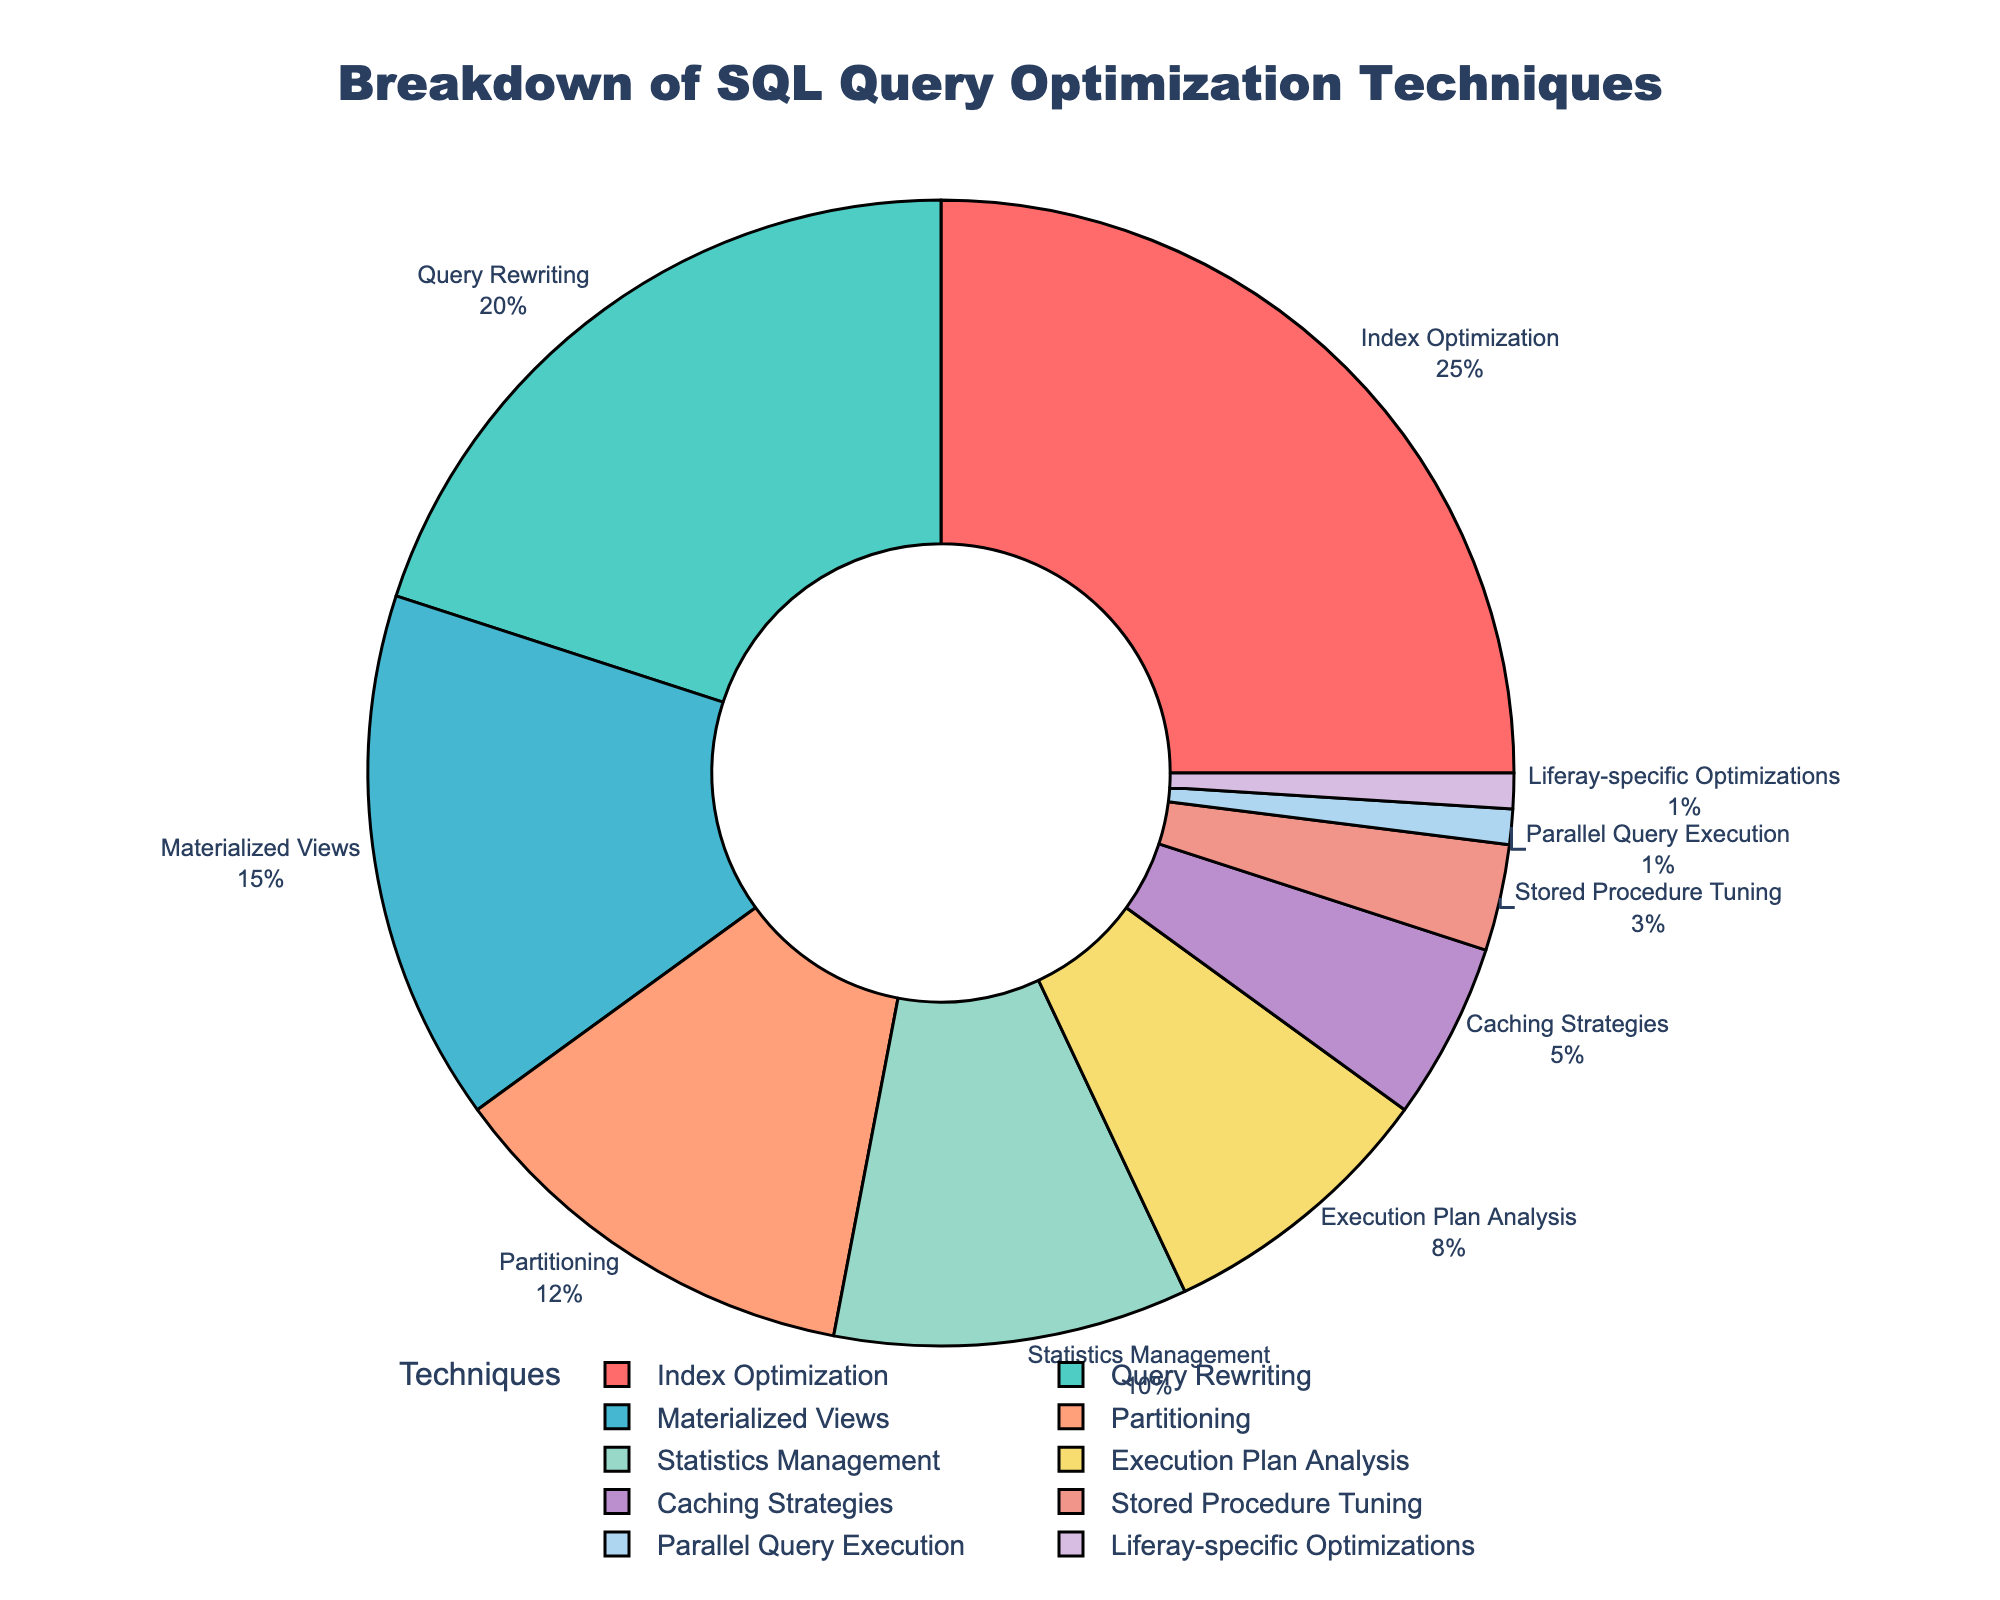What's the most frequently employed SQL query optimization technique according to the chart? The chart shows the breakdown of various SQL query optimization techniques by percentage, and the slice labeled "Index Optimization" is the largest, indicating it has the highest percentage.
Answer: Index Optimization Which technique has a higher percentage, Materialized Views or Partitioning? To determine which technique has a higher percentage, compare the slices labeled "Materialized Views" and "Partitioning". "Materialized Views" has 15%, while "Partitioning" has 12%, so Materialized Views is higher.
Answer: Materialized Views What is the combined percentage of the three least employed optimization techniques? Find the percentages for the three smallest slices: "Stored Procedure Tuning" (3%), "Parallel Query Execution" (1%), and "Liferay-specific Optimizations" (1%). Adding these percentages gives 3% + 1% + 1% = 5%.
Answer: 5% Are there more optimization techniques with percentages above 10% or below 10%? Count the number of techniques above 10%: "Index Optimization" (25%), "Query Rewriting" (20%), "Materialized Views" (15%), and "Partitioning" (12%), totaling 4. Then count those below 10%: "Statistics Management" (10%), "Execution Plan Analysis" (8%), "Caching Strategies" (5%), "Stored Procedure Tuning" (3%), "Parallel Query Execution" (1%), and "Liferay-specific Optimizations" (1%), totaling 6. There are more optimization techniques below 10%.
Answer: Below 10% How much greater is the percentage for Query Rewriting than for Caching Strategies? Subtract the percentage of Caching Strategies (5%) from the percentage of Query Rewriting (20%) to find the difference: 20% - 5% = 15%.
Answer: 15% Which techniques collectively make up less than half of the total percentage? Identify techniques with cumulative percentages less than 50%: "Statistics Management" (10%), "Execution Plan Analysis" (8%), "Caching Strategies" (5%), "Stored Procedure Tuning" (3%), "Parallel Query Execution" (1%), and "Liferay-specific Optimizations" (1%). Adding these gives 10% + 8% + 5% + 3% + 1% + 1% = 28%. These techniques collectively make up less than half.
Answer: Statistics Management, Execution Plan Analysis, Caching Strategies, Stored Procedure Tuning, Parallel Query Execution, Liferay-specific Optimizations What is the total percentage contribution of the top two techniques? Add the percentages of the top two techniques: "Index Optimization" (25%) and "Query Rewriting" (20%), which together give 25% + 20% = 45%.
Answer: 45% Among the techniques, which specific one has the same percentage as the slice colored blue? Identify the slice colored blue and read the label, which is "Partitioning" with a percentage of 12%.
Answer: Partitioning What is the percentage difference between the largest and smallest optimization techniques? Subtract the percentage of the smallest technique "Parallel Query Execution" or "Liferay-specific Optimizations" (both 1%) from the largest "Index Optimization" (25%): 25% - 1% = 24%.
Answer: 24% If you grouped techniques with less than 10% into a single category, what would their combined contribution be? Add the percentages of techniques below 10%: "Execution Plan Analysis" (8%), "Caching Strategies" (5%), "Stored Procedure Tuning" (3%), "Parallel Query Execution" (1%), and "Liferay-specific Optimizations" (1%). This gives 8% + 5% + 3% + 1% + 1% = 18%.
Answer: 18% 